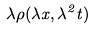Convert formula to latex. <formula><loc_0><loc_0><loc_500><loc_500>\lambda \rho ( \lambda x , \lambda ^ { 2 } t )</formula> 